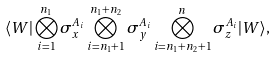Convert formula to latex. <formula><loc_0><loc_0><loc_500><loc_500>\langle W | \bigotimes _ { i = 1 } ^ { n _ { 1 } } \sigma _ { x } ^ { A _ { i } } \bigotimes _ { i = n _ { 1 } + 1 } ^ { n _ { 1 } + n _ { 2 } } \sigma _ { y } ^ { A _ { i } } \bigotimes _ { i = n _ { 1 } + n _ { 2 } + 1 } ^ { n } \sigma _ { z } ^ { A _ { i } } | W \rangle ,</formula> 